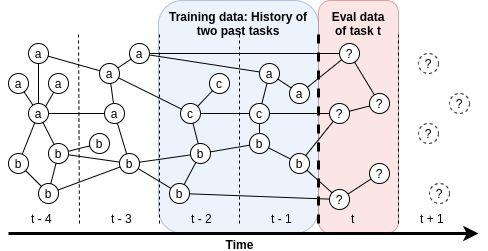What can be inferred about the component 'c' in the context of task performance evaluation? A. 'c' is not considered during the evaluation of tasks. B. 'c' appears to be introduced in the task evaluation at t-2 and remains consistent thereafter. C. 'c' is only used in the training phase and not in the evaluation. D. 'c' has been phased out of the evaluation process over time. The diagram vividly illustrates the involvement of component 'c' in the evaluation process for task performance. Starting from time slice t-2, 'c' is consistently shown in the shaded area labeled as 'Eval data of task t', indicating its integration and steady inclusion in the evaluation framework from that point onwards. This visualization confirms that 'c' was introduced into the task evaluation at t-2 and remains an enduring part of the assessment criteria. Option B is the most accurate interpretation, denoting the continuous and progressive use of 'c' in subsequent evaluations. 